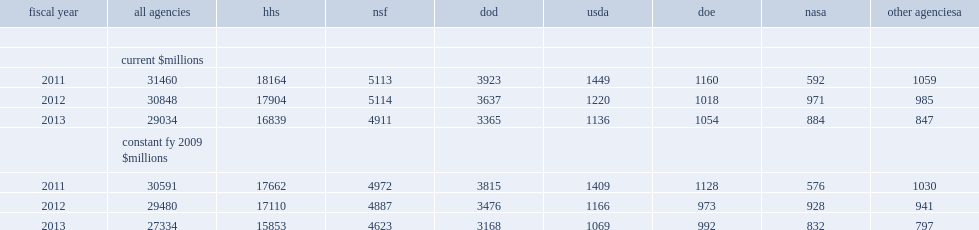How many percent did the department of health and human services (hhs), nsf, and the department of defense (dod) provid of all federally funded academic s&e obligations in fy 2013? 0.86502. How many percent did hhs account of all federally funded obligations? 0.579975. How many percent did nsf account of all federally funded obligations? 0.169147. How many percent did dod account of all federally funded obligations? 0.115899. 